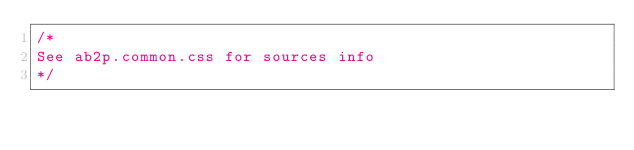Convert code to text. <code><loc_0><loc_0><loc_500><loc_500><_CSS_>/*
See ab2p.common.css for sources info
*/</code> 